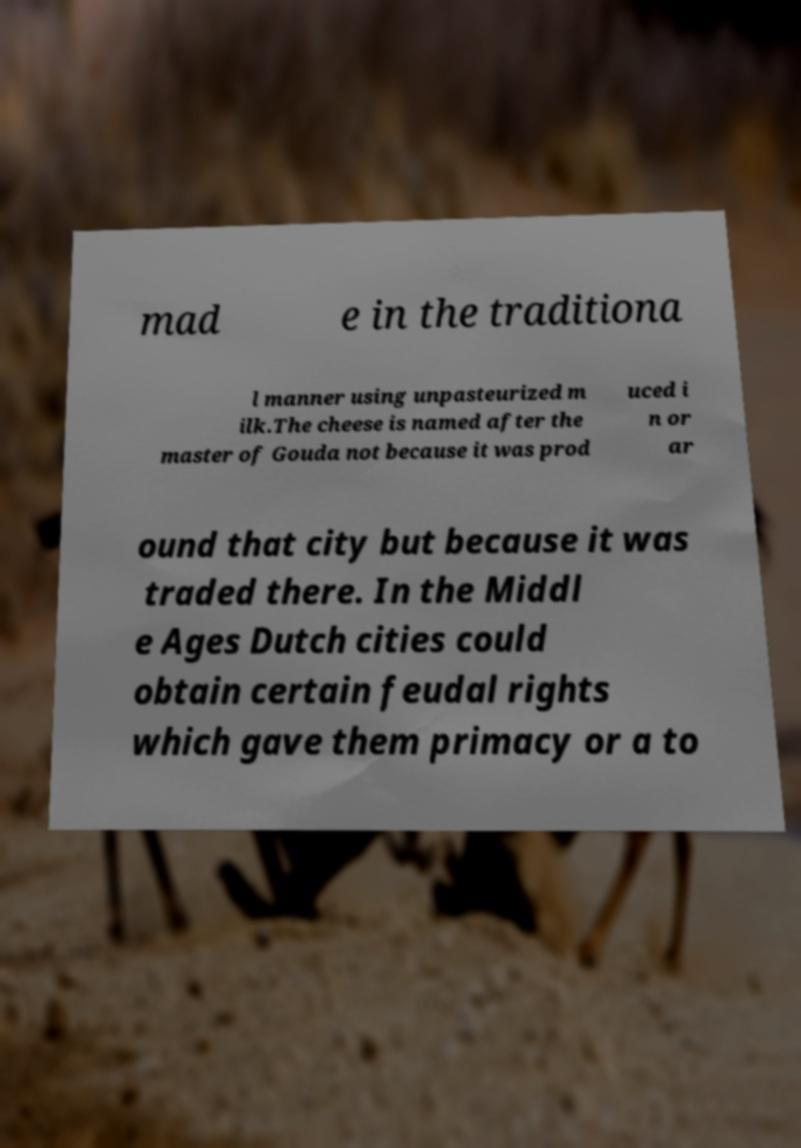Could you extract and type out the text from this image? mad e in the traditiona l manner using unpasteurized m ilk.The cheese is named after the master of Gouda not because it was prod uced i n or ar ound that city but because it was traded there. In the Middl e Ages Dutch cities could obtain certain feudal rights which gave them primacy or a to 